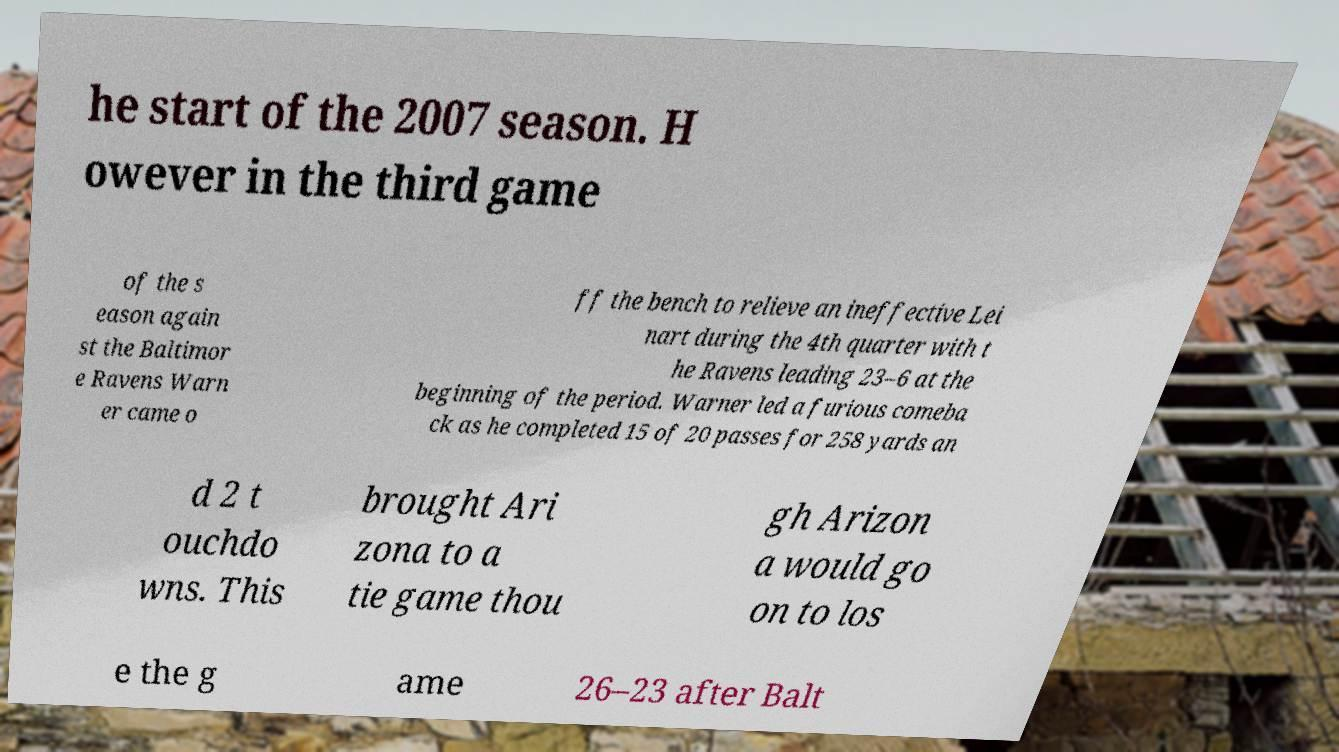For documentation purposes, I need the text within this image transcribed. Could you provide that? he start of the 2007 season. H owever in the third game of the s eason again st the Baltimor e Ravens Warn er came o ff the bench to relieve an ineffective Lei nart during the 4th quarter with t he Ravens leading 23–6 at the beginning of the period. Warner led a furious comeba ck as he completed 15 of 20 passes for 258 yards an d 2 t ouchdo wns. This brought Ari zona to a tie game thou gh Arizon a would go on to los e the g ame 26–23 after Balt 